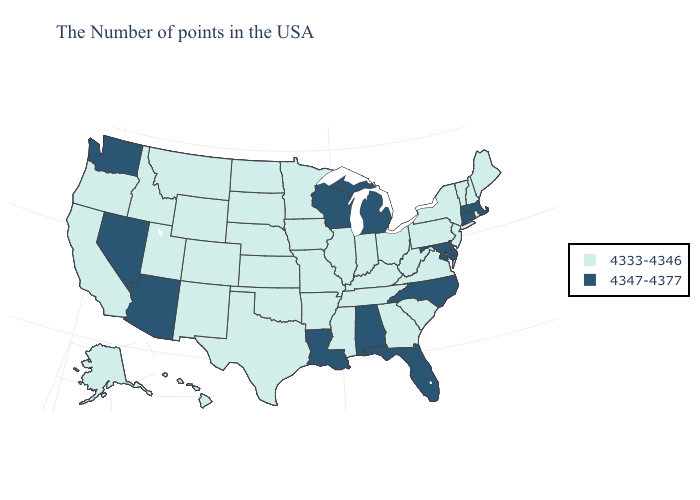Name the states that have a value in the range 4333-4346?
Concise answer only. Maine, Rhode Island, New Hampshire, Vermont, New York, New Jersey, Pennsylvania, Virginia, South Carolina, West Virginia, Ohio, Georgia, Kentucky, Indiana, Tennessee, Illinois, Mississippi, Missouri, Arkansas, Minnesota, Iowa, Kansas, Nebraska, Oklahoma, Texas, South Dakota, North Dakota, Wyoming, Colorado, New Mexico, Utah, Montana, Idaho, California, Oregon, Alaska, Hawaii. What is the value of Ohio?
Write a very short answer. 4333-4346. Does Alabama have the lowest value in the South?
Answer briefly. No. Does Arizona have the highest value in the USA?
Answer briefly. Yes. What is the lowest value in the West?
Quick response, please. 4333-4346. What is the value of Colorado?
Give a very brief answer. 4333-4346. What is the value of West Virginia?
Give a very brief answer. 4333-4346. Name the states that have a value in the range 4347-4377?
Short answer required. Massachusetts, Connecticut, Delaware, Maryland, North Carolina, Florida, Michigan, Alabama, Wisconsin, Louisiana, Arizona, Nevada, Washington. Does the map have missing data?
Answer briefly. No. Name the states that have a value in the range 4333-4346?
Short answer required. Maine, Rhode Island, New Hampshire, Vermont, New York, New Jersey, Pennsylvania, Virginia, South Carolina, West Virginia, Ohio, Georgia, Kentucky, Indiana, Tennessee, Illinois, Mississippi, Missouri, Arkansas, Minnesota, Iowa, Kansas, Nebraska, Oklahoma, Texas, South Dakota, North Dakota, Wyoming, Colorado, New Mexico, Utah, Montana, Idaho, California, Oregon, Alaska, Hawaii. Is the legend a continuous bar?
Be succinct. No. Does New Mexico have the highest value in the USA?
Answer briefly. No. What is the value of California?
Answer briefly. 4333-4346. Name the states that have a value in the range 4333-4346?
Short answer required. Maine, Rhode Island, New Hampshire, Vermont, New York, New Jersey, Pennsylvania, Virginia, South Carolina, West Virginia, Ohio, Georgia, Kentucky, Indiana, Tennessee, Illinois, Mississippi, Missouri, Arkansas, Minnesota, Iowa, Kansas, Nebraska, Oklahoma, Texas, South Dakota, North Dakota, Wyoming, Colorado, New Mexico, Utah, Montana, Idaho, California, Oregon, Alaska, Hawaii. Among the states that border Montana , which have the lowest value?
Keep it brief. South Dakota, North Dakota, Wyoming, Idaho. 